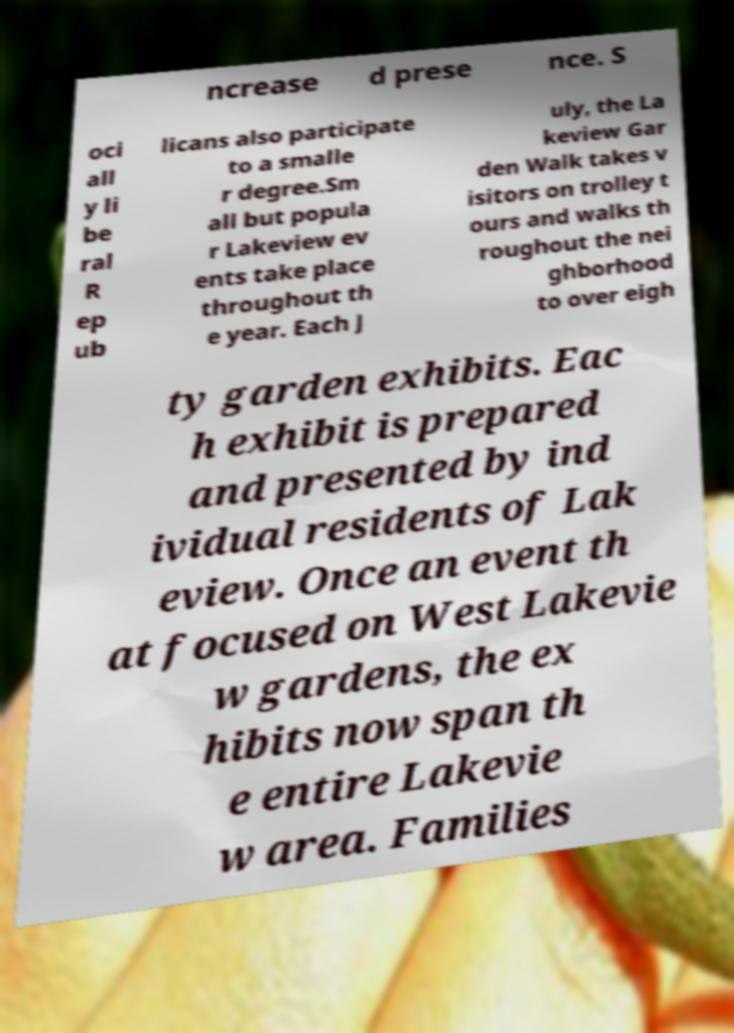I need the written content from this picture converted into text. Can you do that? ncrease d prese nce. S oci all y li be ral R ep ub licans also participate to a smalle r degree.Sm all but popula r Lakeview ev ents take place throughout th e year. Each J uly, the La keview Gar den Walk takes v isitors on trolley t ours and walks th roughout the nei ghborhood to over eigh ty garden exhibits. Eac h exhibit is prepared and presented by ind ividual residents of Lak eview. Once an event th at focused on West Lakevie w gardens, the ex hibits now span th e entire Lakevie w area. Families 